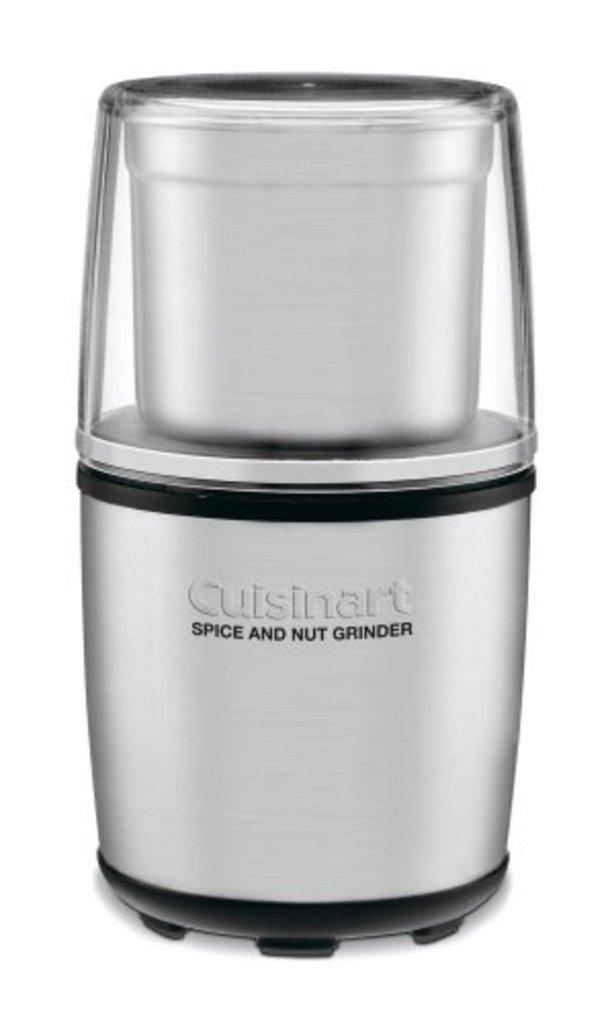What is the main object in the picture? There is a grinder in the picture. Where is the grinder located? The grinder is placed on a white surface. Is there any branding or logo on the grinder? Yes, the grinder has a logo printed on it. How many cars are flying in the sky in the image? There are no cars visible in the image, let alone flying in the sky. 